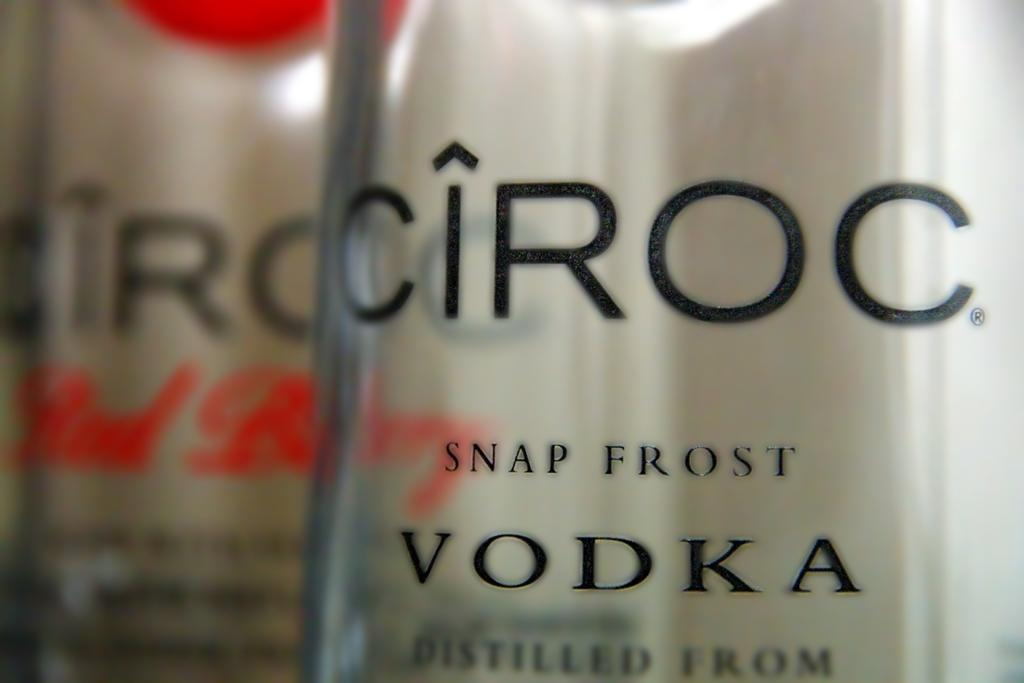<image>
Describe the image concisely. the word vodka is on a drink that is clear 